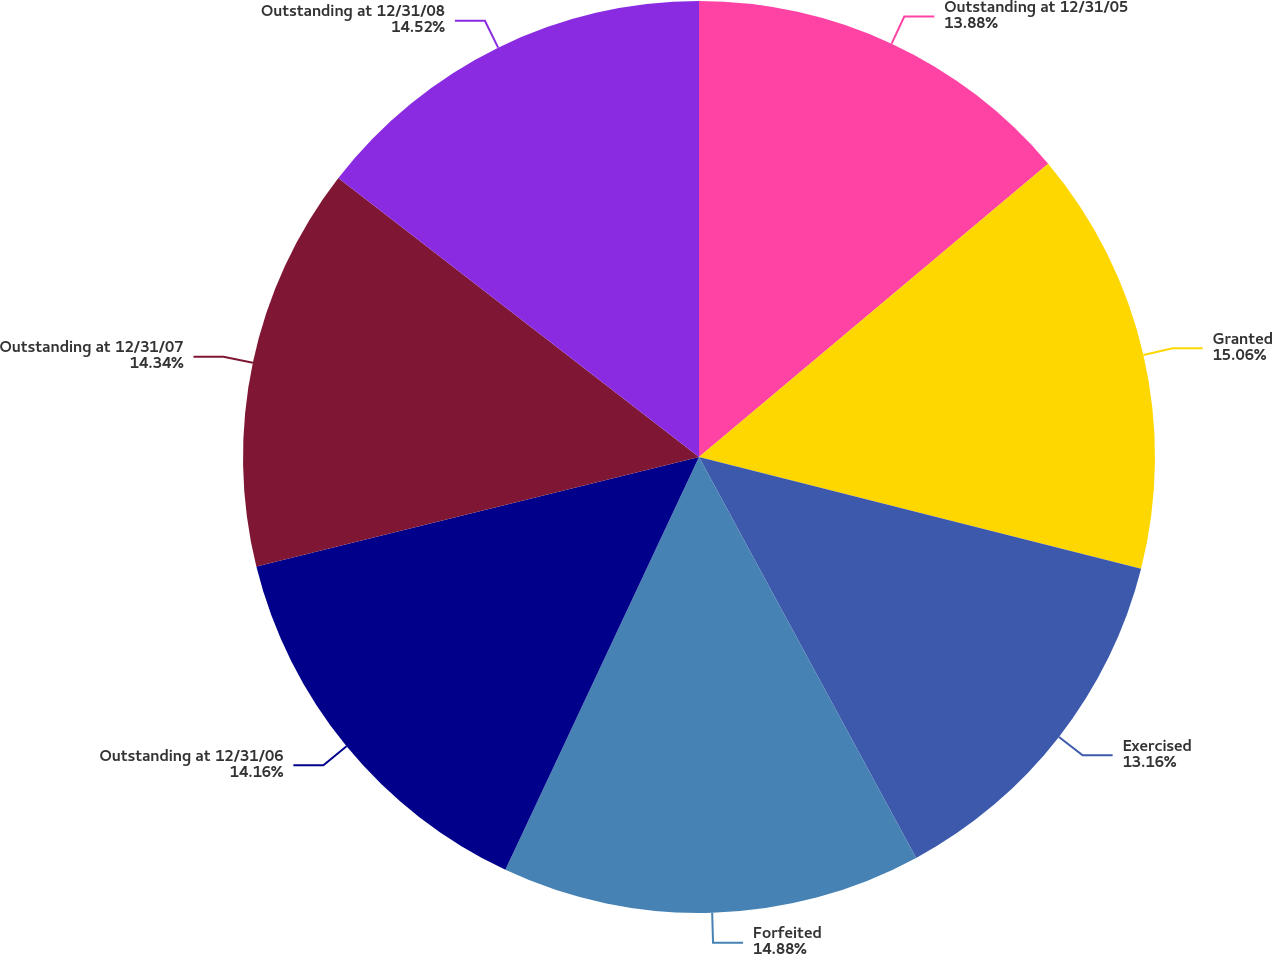Convert chart. <chart><loc_0><loc_0><loc_500><loc_500><pie_chart><fcel>Outstanding at 12/31/05<fcel>Granted<fcel>Exercised<fcel>Forfeited<fcel>Outstanding at 12/31/06<fcel>Outstanding at 12/31/07<fcel>Outstanding at 12/31/08<nl><fcel>13.88%<fcel>15.06%<fcel>13.16%<fcel>14.88%<fcel>14.16%<fcel>14.34%<fcel>14.52%<nl></chart> 